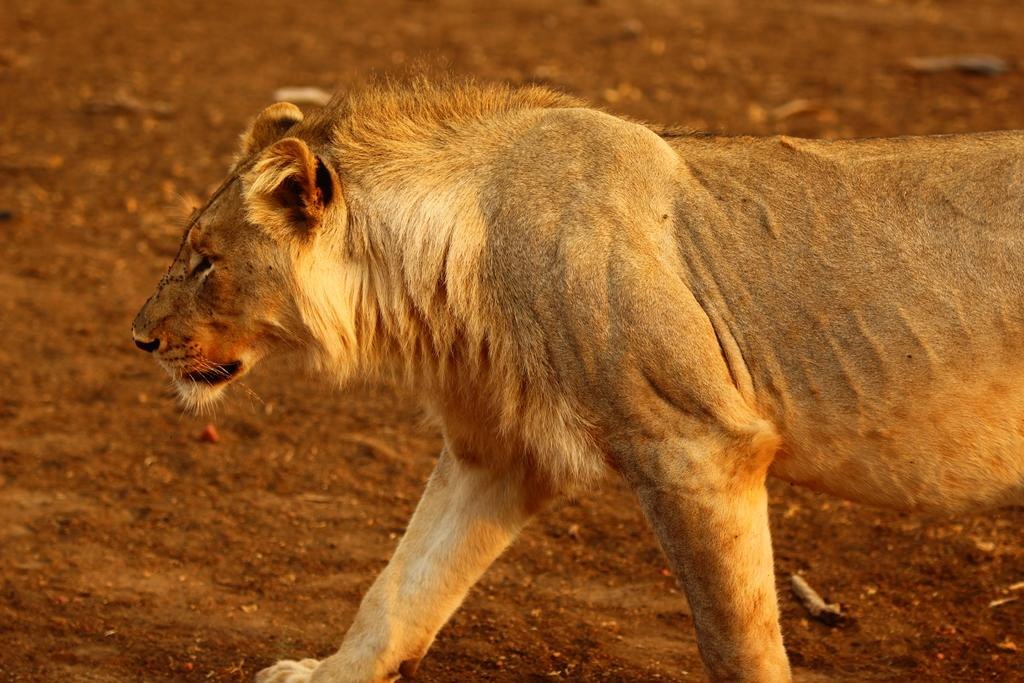What type of animal is in the image? The specific type of animal cannot be determined from the provided facts. What is the animal standing in or interacting with in the image? There is mud in the image, which the animal may be standing in or interacting with. What type of shade does the vase provide in the image? There is no vase present in the image, so it cannot provide any shade. 